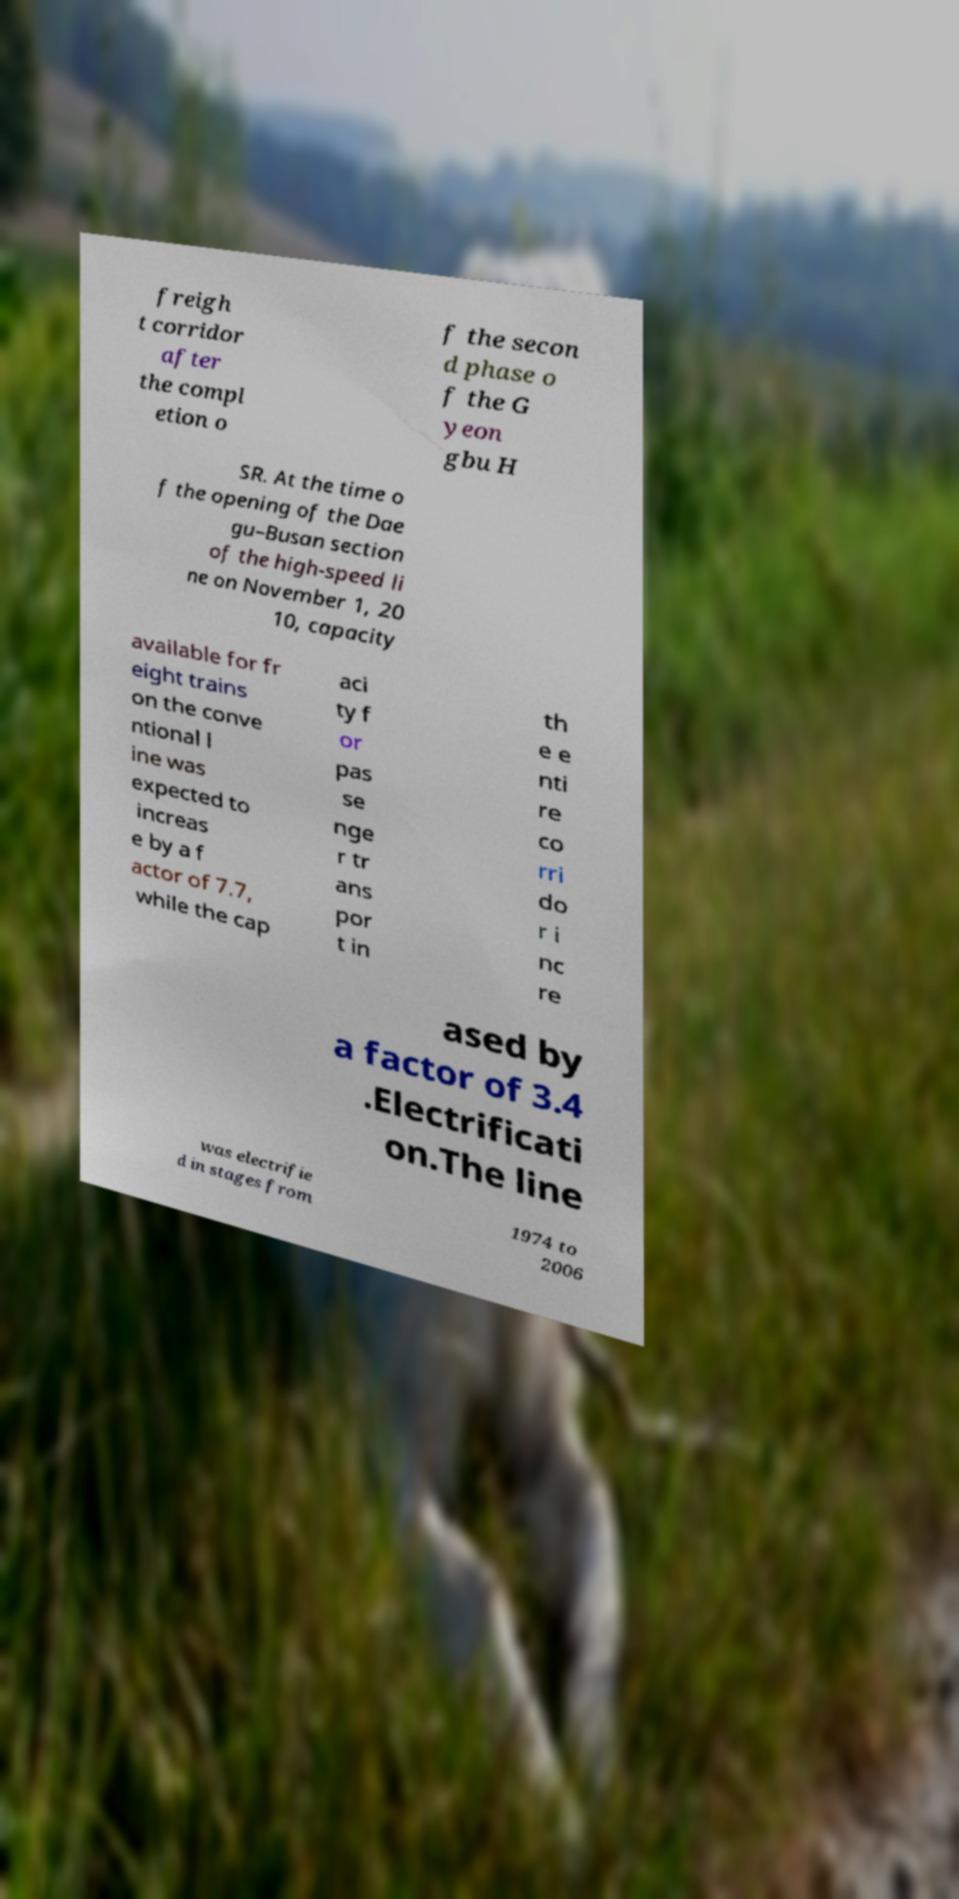Please read and relay the text visible in this image. What does it say? freigh t corridor after the compl etion o f the secon d phase o f the G yeon gbu H SR. At the time o f the opening of the Dae gu–Busan section of the high-speed li ne on November 1, 20 10, capacity available for fr eight trains on the conve ntional l ine was expected to increas e by a f actor of 7.7, while the cap aci ty f or pas se nge r tr ans por t in th e e nti re co rri do r i nc re ased by a factor of 3.4 .Electrificati on.The line was electrifie d in stages from 1974 to 2006 